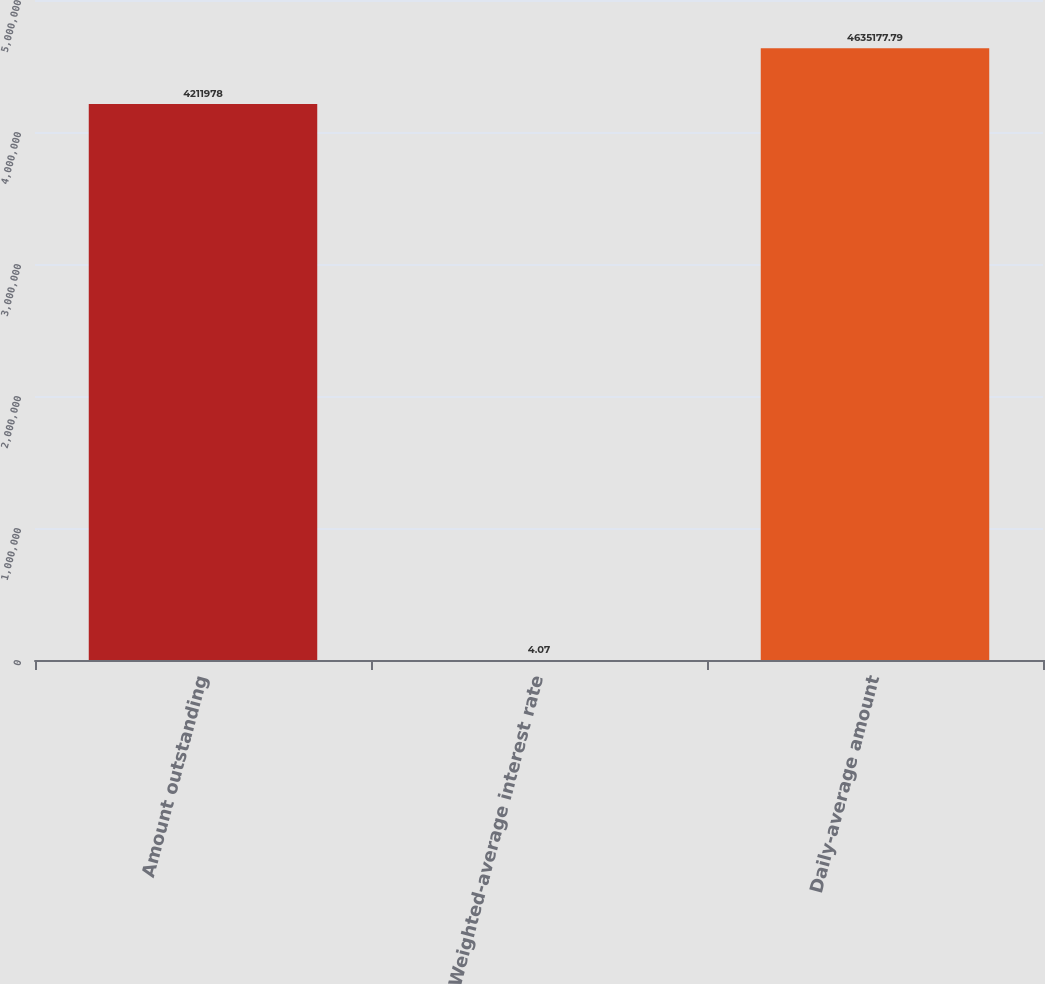Convert chart. <chart><loc_0><loc_0><loc_500><loc_500><bar_chart><fcel>Amount outstanding<fcel>Weighted-average interest rate<fcel>Daily-average amount<nl><fcel>4.21198e+06<fcel>4.07<fcel>4.63518e+06<nl></chart> 